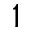<formula> <loc_0><loc_0><loc_500><loc_500>1</formula> 